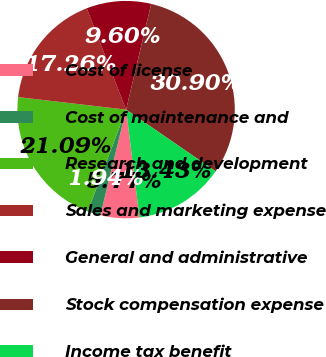Convert chart to OTSL. <chart><loc_0><loc_0><loc_500><loc_500><pie_chart><fcel>Cost of license<fcel>Cost of maintenance and<fcel>Research and development<fcel>Sales and marketing expense<fcel>General and administrative<fcel>Stock compensation expense<fcel>Income tax benefit<nl><fcel>5.77%<fcel>1.94%<fcel>21.09%<fcel>17.26%<fcel>9.6%<fcel>30.89%<fcel>13.43%<nl></chart> 